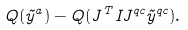Convert formula to latex. <formula><loc_0><loc_0><loc_500><loc_500>Q ( \vec { y } ^ { a } ) - Q ( J ^ { T } I J ^ { q c } \vec { y } ^ { q c } ) .</formula> 